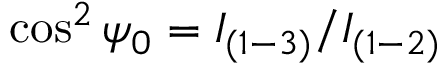<formula> <loc_0><loc_0><loc_500><loc_500>\cos ^ { 2 } \psi _ { 0 } = I _ { ( 1 - 3 ) } / I _ { ( 1 - 2 ) }</formula> 